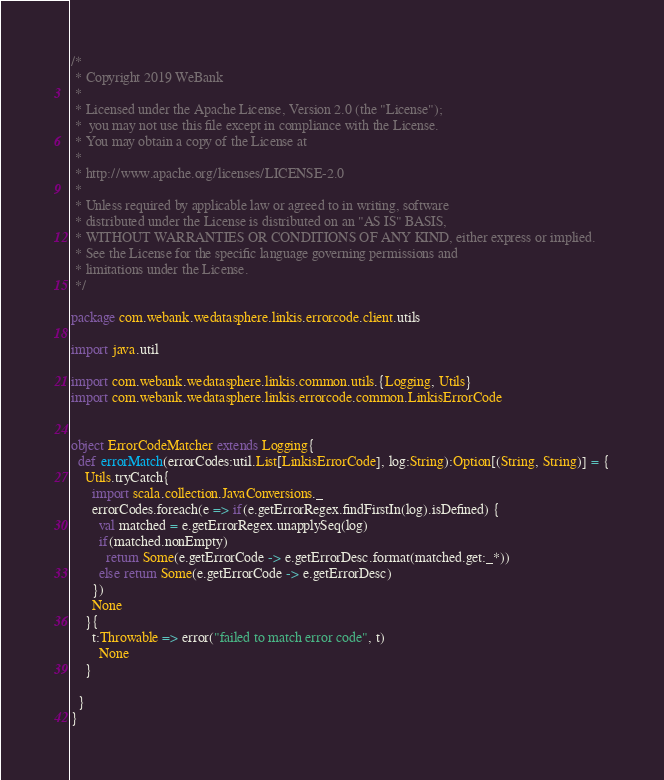Convert code to text. <code><loc_0><loc_0><loc_500><loc_500><_Scala_>/*
 * Copyright 2019 WeBank
 *
 * Licensed under the Apache License, Version 2.0 (the "License");
 *  you may not use this file except in compliance with the License.
 * You may obtain a copy of the License at
 *
 * http://www.apache.org/licenses/LICENSE-2.0
 *
 * Unless required by applicable law or agreed to in writing, software
 * distributed under the License is distributed on an "AS IS" BASIS,
 * WITHOUT WARRANTIES OR CONDITIONS OF ANY KIND, either express or implied.
 * See the License for the specific language governing permissions and
 * limitations under the License.
 */

package com.webank.wedatasphere.linkis.errorcode.client.utils

import java.util

import com.webank.wedatasphere.linkis.common.utils.{Logging, Utils}
import com.webank.wedatasphere.linkis.errorcode.common.LinkisErrorCode


object ErrorCodeMatcher extends Logging{
  def errorMatch(errorCodes:util.List[LinkisErrorCode], log:String):Option[(String, String)] = {
    Utils.tryCatch{
      import scala.collection.JavaConversions._
      errorCodes.foreach(e => if(e.getErrorRegex.findFirstIn(log).isDefined) {
        val matched = e.getErrorRegex.unapplySeq(log)
        if(matched.nonEmpty)
          return Some(e.getErrorCode -> e.getErrorDesc.format(matched.get:_*))
        else return Some(e.getErrorCode -> e.getErrorDesc)
      })
      None
    }{
      t:Throwable => error("failed to match error code", t)
        None
    }

  }
}
</code> 